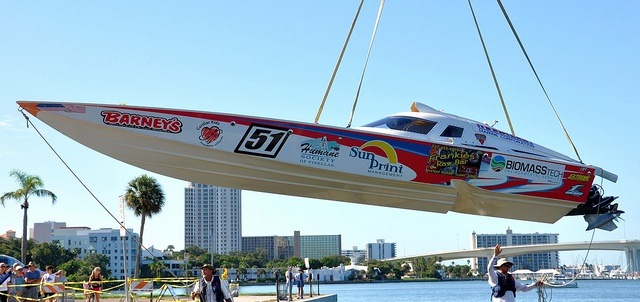Describe the objects in this image and their specific colors. I can see boat in lightblue, gray, maroon, and black tones, people in lightblue, black, gray, and white tones, people in lightblue, black, darkgray, gray, and maroon tones, people in lightblue, black, brown, maroon, and gray tones, and people in lightblue, black, navy, maroon, and gray tones in this image. 